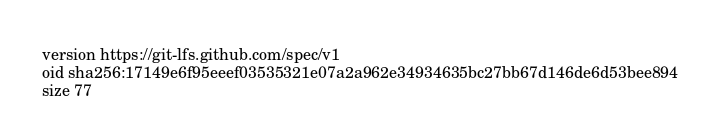<code> <loc_0><loc_0><loc_500><loc_500><_YAML_>version https://git-lfs.github.com/spec/v1
oid sha256:17149e6f95eeef03535321e07a2a962e34934635bc27bb67d146de6d53bee894
size 77
</code> 